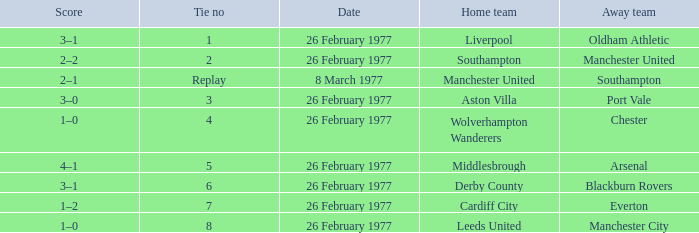What's the result when the wolverhampton wanderers competed at home? 1–0. 